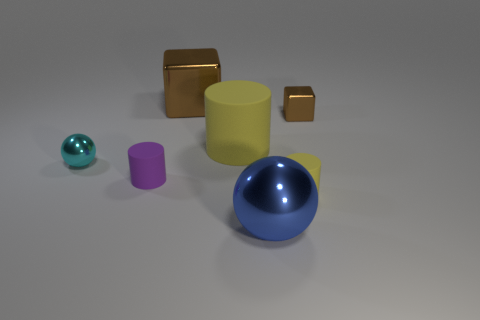Subtract all red balls. Subtract all red blocks. How many balls are left? 2 Add 1 large green shiny blocks. How many objects exist? 8 Subtract all spheres. How many objects are left? 5 Add 7 tiny purple matte cylinders. How many tiny purple matte cylinders exist? 8 Subtract 0 gray blocks. How many objects are left? 7 Subtract all big matte objects. Subtract all red rubber blocks. How many objects are left? 6 Add 4 large blue shiny objects. How many large blue shiny objects are left? 5 